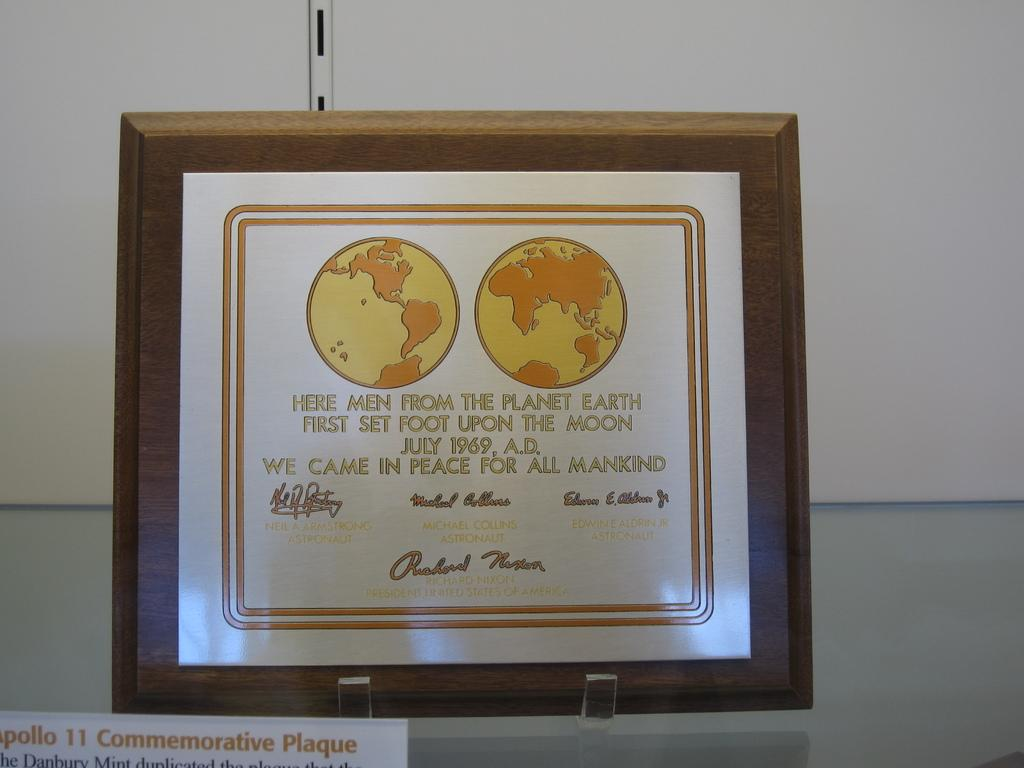<image>
Offer a succinct explanation of the picture presented. Men from earth set foot on the moon in July 